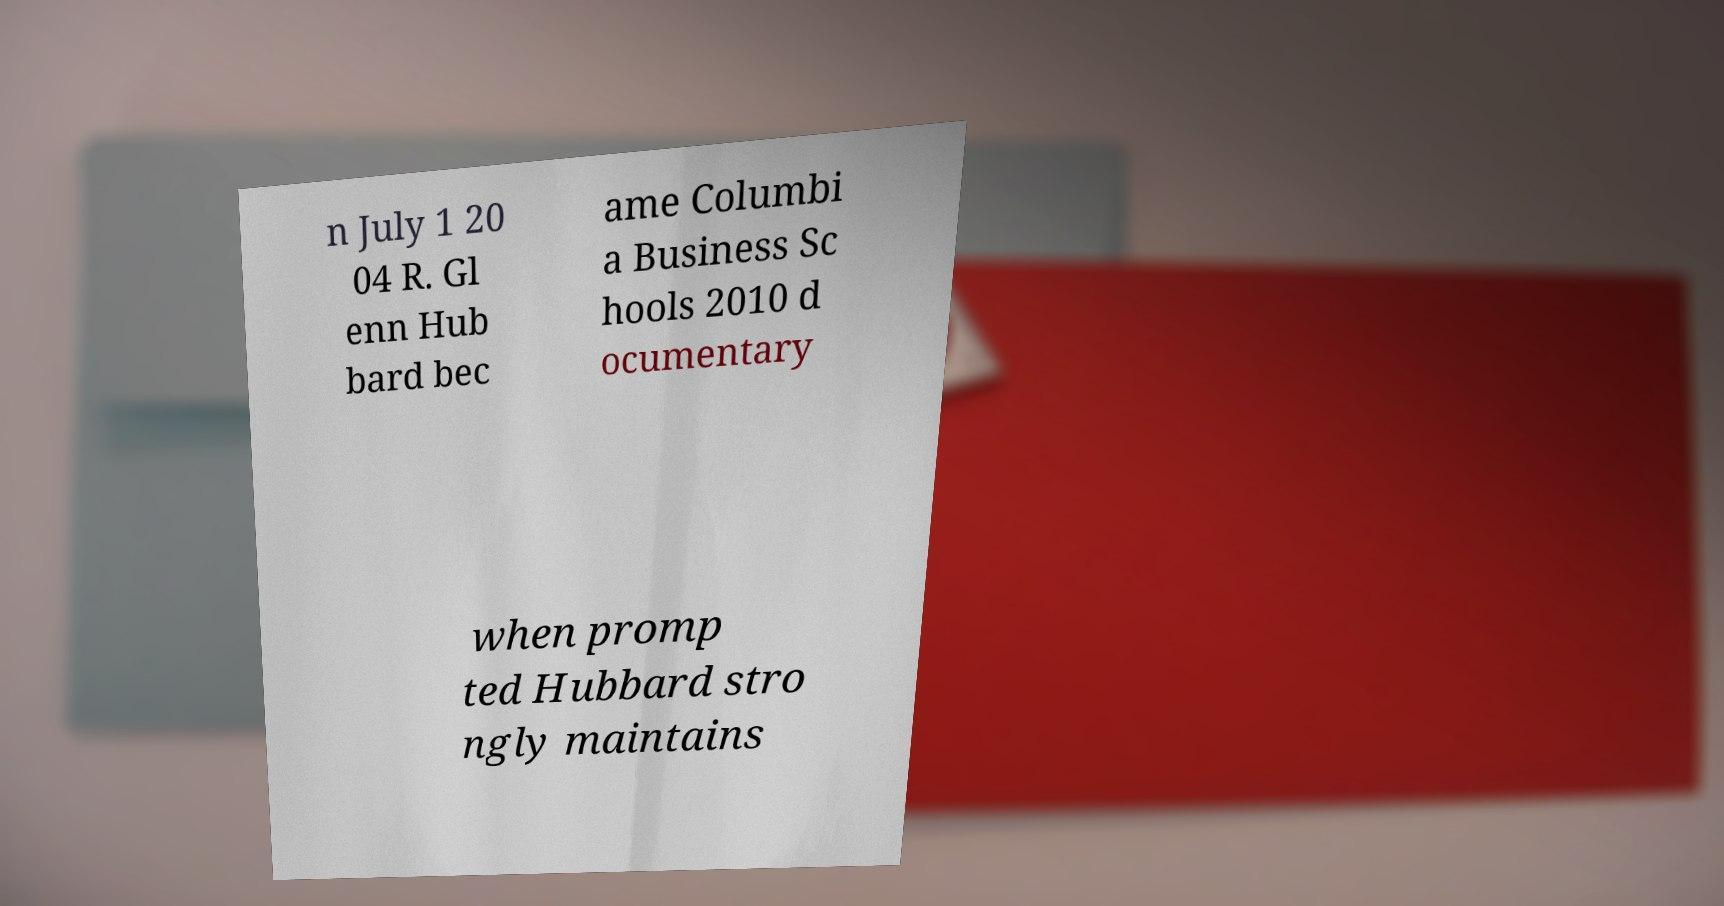Can you accurately transcribe the text from the provided image for me? n July 1 20 04 R. Gl enn Hub bard bec ame Columbi a Business Sc hools 2010 d ocumentary when promp ted Hubbard stro ngly maintains 